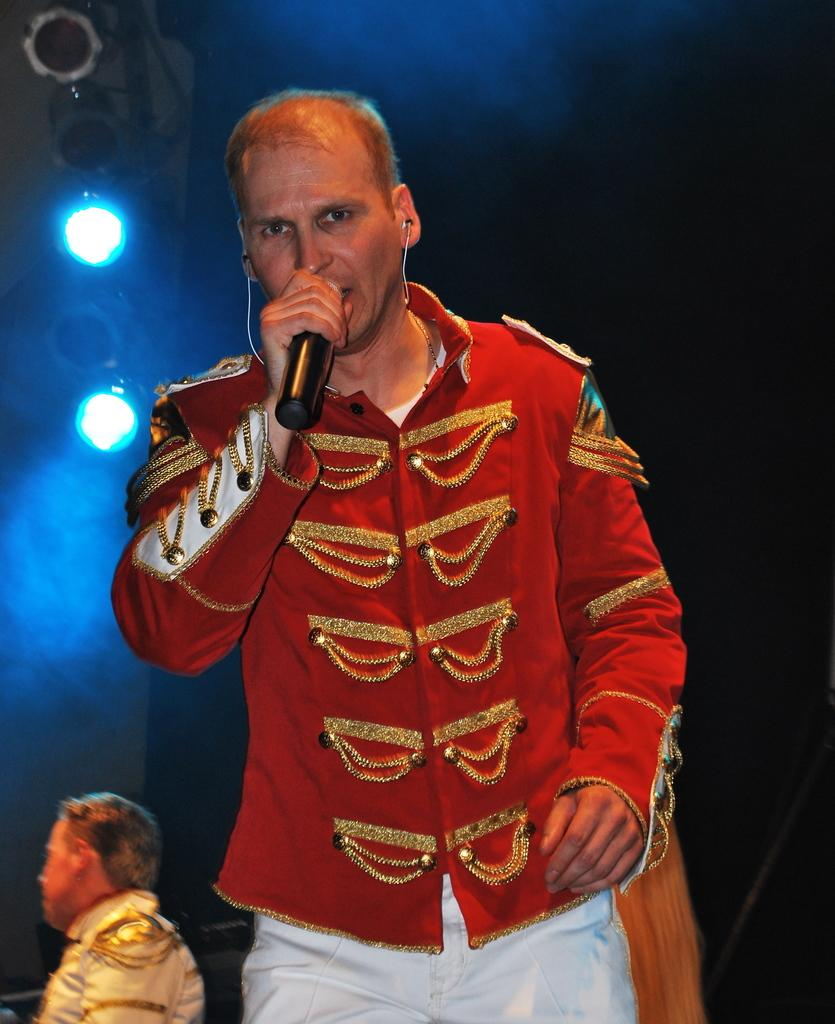What is the person in the foreground of the image doing? The person in the foreground of the image is standing and holding a microphone. Can you describe the person in the background of the image? There is another person visible in the background of the image. What can be seen at the top of the image? There are lights visible at the top of the image. What type of play is being performed on the station in the image? There is no play or station present in the image; it features a person holding a microphone and another person in the background. 